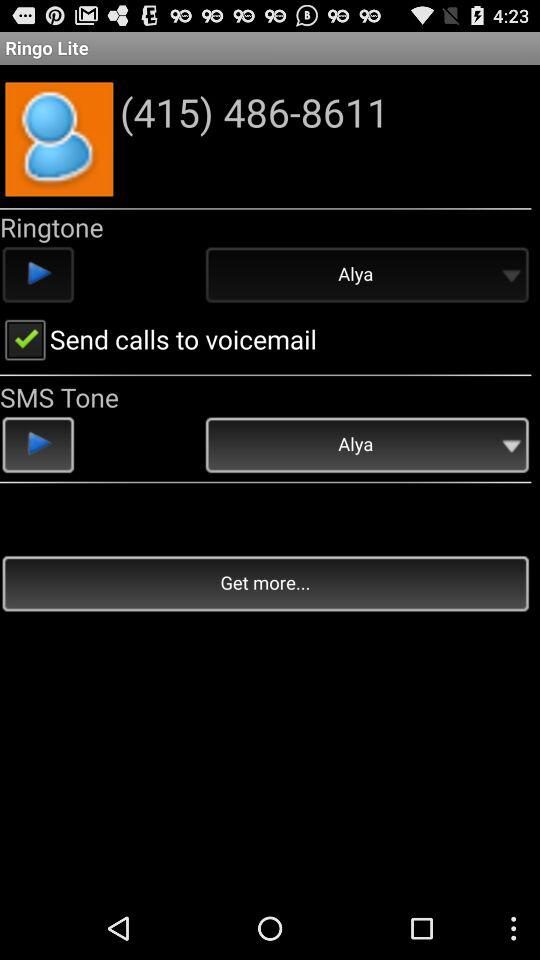Which option has been selected in "SMS Tone"? The selected option in "SMS Tone" is "Alya". 